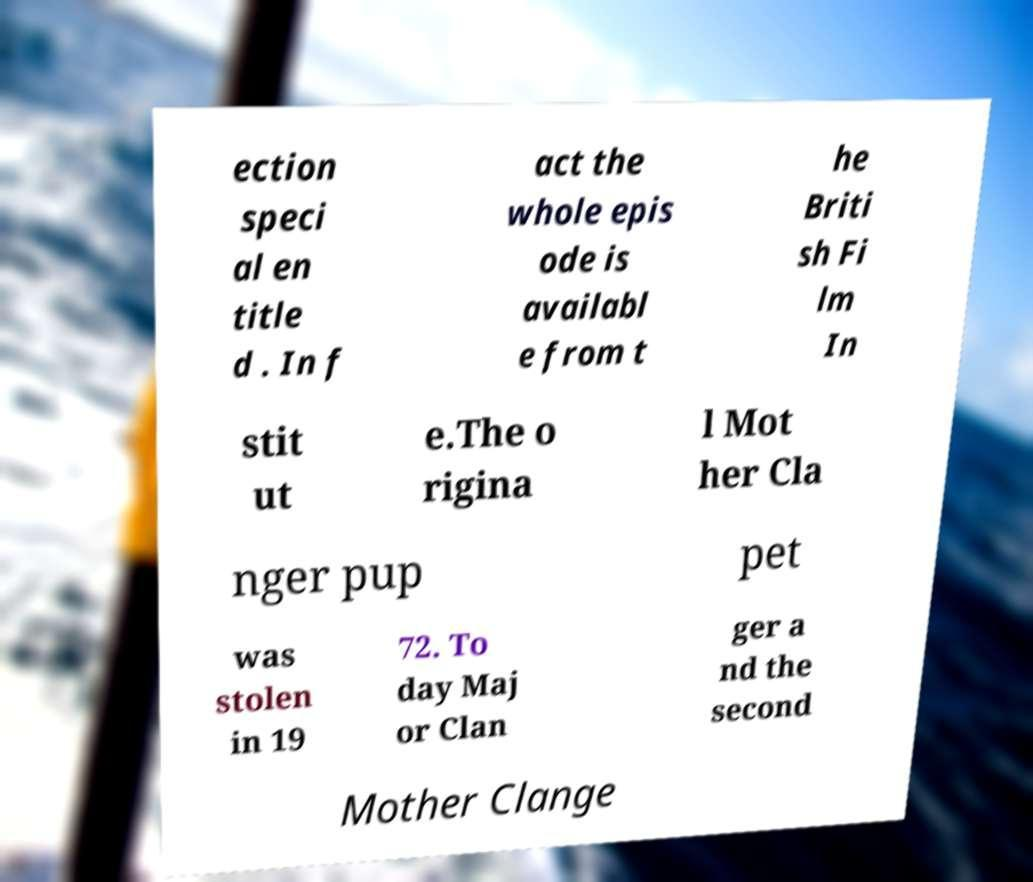Please identify and transcribe the text found in this image. ection speci al en title d . In f act the whole epis ode is availabl e from t he Briti sh Fi lm In stit ut e.The o rigina l Mot her Cla nger pup pet was stolen in 19 72. To day Maj or Clan ger a nd the second Mother Clange 